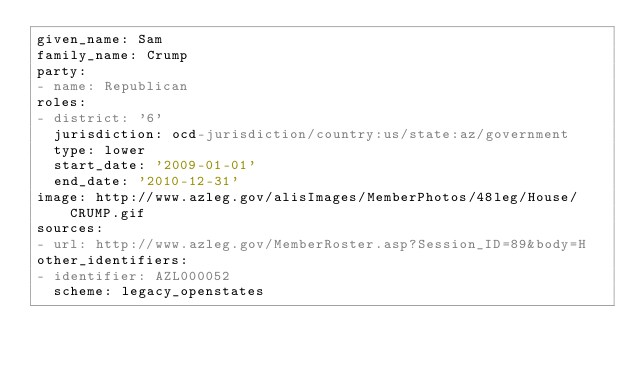<code> <loc_0><loc_0><loc_500><loc_500><_YAML_>given_name: Sam
family_name: Crump
party:
- name: Republican
roles:
- district: '6'
  jurisdiction: ocd-jurisdiction/country:us/state:az/government
  type: lower
  start_date: '2009-01-01'
  end_date: '2010-12-31'
image: http://www.azleg.gov/alisImages/MemberPhotos/48leg/House/CRUMP.gif
sources:
- url: http://www.azleg.gov/MemberRoster.asp?Session_ID=89&body=H
other_identifiers:
- identifier: AZL000052
  scheme: legacy_openstates
</code> 